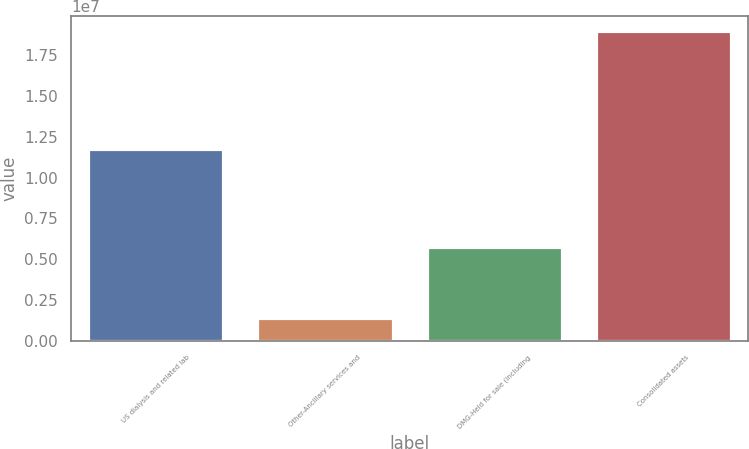Convert chart. <chart><loc_0><loc_0><loc_500><loc_500><bar_chart><fcel>US dialysis and related lab<fcel>Other-Ancillary services and<fcel>DMG-Held for sale (including<fcel>Consolidated assets<nl><fcel>1.1776e+07<fcel>1.41051e+06<fcel>5.76164e+06<fcel>1.89482e+07<nl></chart> 